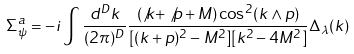Convert formula to latex. <formula><loc_0><loc_0><loc_500><loc_500>\Sigma _ { \psi } ^ { a } = - i \int \frac { d ^ { D } k } { ( 2 \pi ) ^ { D } } \frac { ( \not k + \not p + M ) \cos ^ { 2 } ( k \wedge p ) } { [ ( k + p ) ^ { 2 } - M ^ { 2 } ] [ k ^ { 2 } - 4 M ^ { 2 } ] } \Delta _ { \lambda } ( k )</formula> 